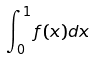Convert formula to latex. <formula><loc_0><loc_0><loc_500><loc_500>\int _ { 0 } ^ { 1 } f ( x ) d x</formula> 